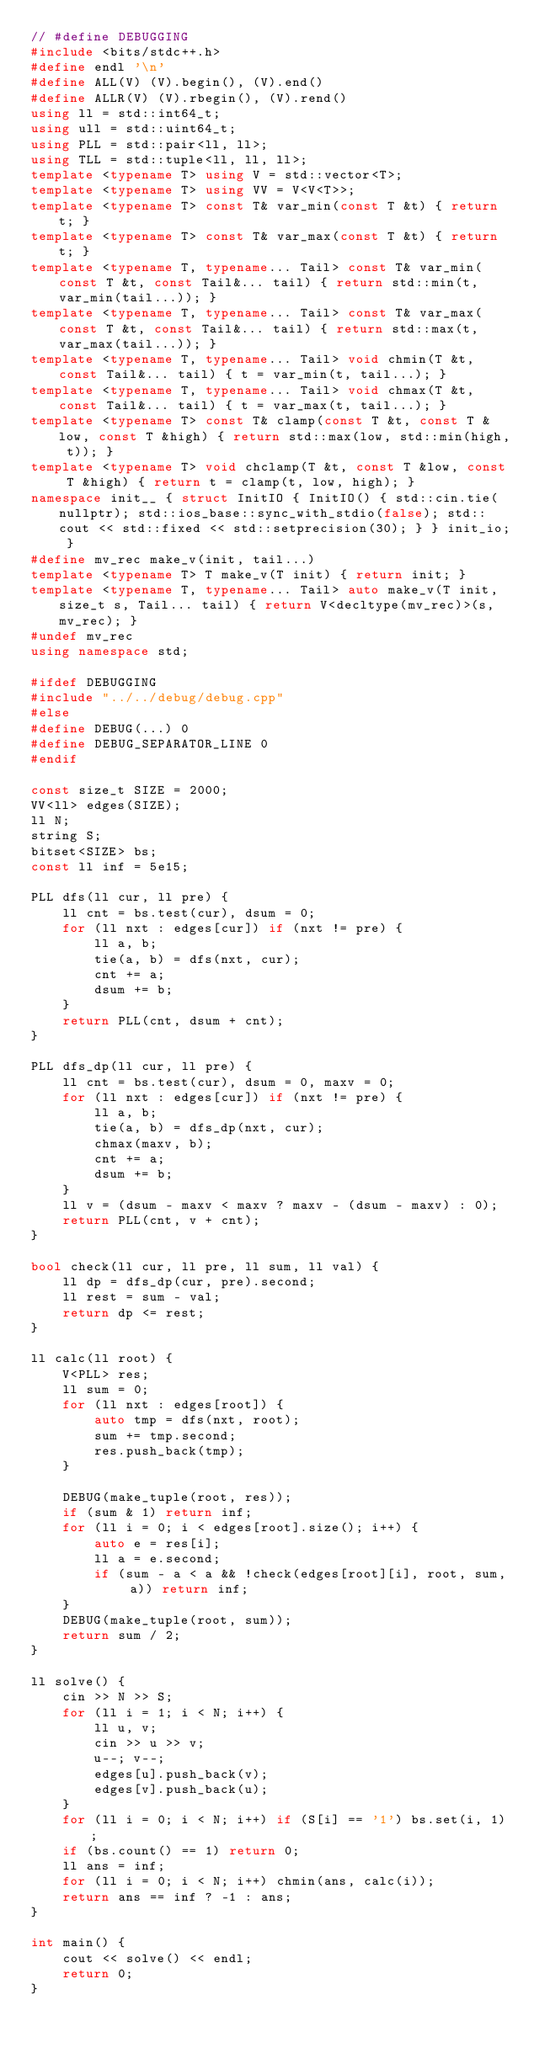Convert code to text. <code><loc_0><loc_0><loc_500><loc_500><_C++_>// #define DEBUGGING
#include <bits/stdc++.h>
#define endl '\n'
#define ALL(V) (V).begin(), (V).end()
#define ALLR(V) (V).rbegin(), (V).rend()
using ll = std::int64_t;
using ull = std::uint64_t;
using PLL = std::pair<ll, ll>;
using TLL = std::tuple<ll, ll, ll>;
template <typename T> using V = std::vector<T>;
template <typename T> using VV = V<V<T>>;
template <typename T> const T& var_min(const T &t) { return t; }
template <typename T> const T& var_max(const T &t) { return t; }
template <typename T, typename... Tail> const T& var_min(const T &t, const Tail&... tail) { return std::min(t, var_min(tail...)); }
template <typename T, typename... Tail> const T& var_max(const T &t, const Tail&... tail) { return std::max(t, var_max(tail...)); }
template <typename T, typename... Tail> void chmin(T &t, const Tail&... tail) { t = var_min(t, tail...); }
template <typename T, typename... Tail> void chmax(T &t, const Tail&... tail) { t = var_max(t, tail...); }
template <typename T> const T& clamp(const T &t, const T &low, const T &high) { return std::max(low, std::min(high, t)); }
template <typename T> void chclamp(T &t, const T &low, const T &high) { return t = clamp(t, low, high); }
namespace init__ { struct InitIO { InitIO() { std::cin.tie(nullptr); std::ios_base::sync_with_stdio(false); std::cout << std::fixed << std::setprecision(30); } } init_io; }
#define mv_rec make_v(init, tail...)
template <typename T> T make_v(T init) { return init; }
template <typename T, typename... Tail> auto make_v(T init, size_t s, Tail... tail) { return V<decltype(mv_rec)>(s, mv_rec); }
#undef mv_rec
using namespace std;

#ifdef DEBUGGING
#include "../../debug/debug.cpp"
#else
#define DEBUG(...) 0
#define DEBUG_SEPARATOR_LINE 0
#endif

const size_t SIZE = 2000;
VV<ll> edges(SIZE);
ll N;
string S;
bitset<SIZE> bs;
const ll inf = 5e15;

PLL dfs(ll cur, ll pre) {
    ll cnt = bs.test(cur), dsum = 0;
    for (ll nxt : edges[cur]) if (nxt != pre) {
        ll a, b;
        tie(a, b) = dfs(nxt, cur);
        cnt += a;
        dsum += b;
    }
    return PLL(cnt, dsum + cnt);
}

PLL dfs_dp(ll cur, ll pre) {
    ll cnt = bs.test(cur), dsum = 0, maxv = 0;
    for (ll nxt : edges[cur]) if (nxt != pre) {
        ll a, b;
        tie(a, b) = dfs_dp(nxt, cur);
        chmax(maxv, b);
        cnt += a;
        dsum += b;
    }
    ll v = (dsum - maxv < maxv ? maxv - (dsum - maxv) : 0);
    return PLL(cnt, v + cnt);
}

bool check(ll cur, ll pre, ll sum, ll val) {
    ll dp = dfs_dp(cur, pre).second;
    ll rest = sum - val;
    return dp <= rest;
}

ll calc(ll root) {
    V<PLL> res;
    ll sum = 0;
    for (ll nxt : edges[root]) {
        auto tmp = dfs(nxt, root);
        sum += tmp.second;
        res.push_back(tmp);
    }

    DEBUG(make_tuple(root, res));
    if (sum & 1) return inf;
    for (ll i = 0; i < edges[root].size(); i++) {
        auto e = res[i];
        ll a = e.second;
        if (sum - a < a && !check(edges[root][i], root, sum, a)) return inf;
    }
    DEBUG(make_tuple(root, sum));
    return sum / 2;
}

ll solve() {
    cin >> N >> S;
    for (ll i = 1; i < N; i++) {
        ll u, v;
        cin >> u >> v;
        u--; v--;
        edges[u].push_back(v);
        edges[v].push_back(u);
    }
    for (ll i = 0; i < N; i++) if (S[i] == '1') bs.set(i, 1);
    if (bs.count() == 1) return 0;
    ll ans = inf;
    for (ll i = 0; i < N; i++) chmin(ans, calc(i));
    return ans == inf ? -1 : ans;
}

int main() {
    cout << solve() << endl;
    return 0;
}
</code> 